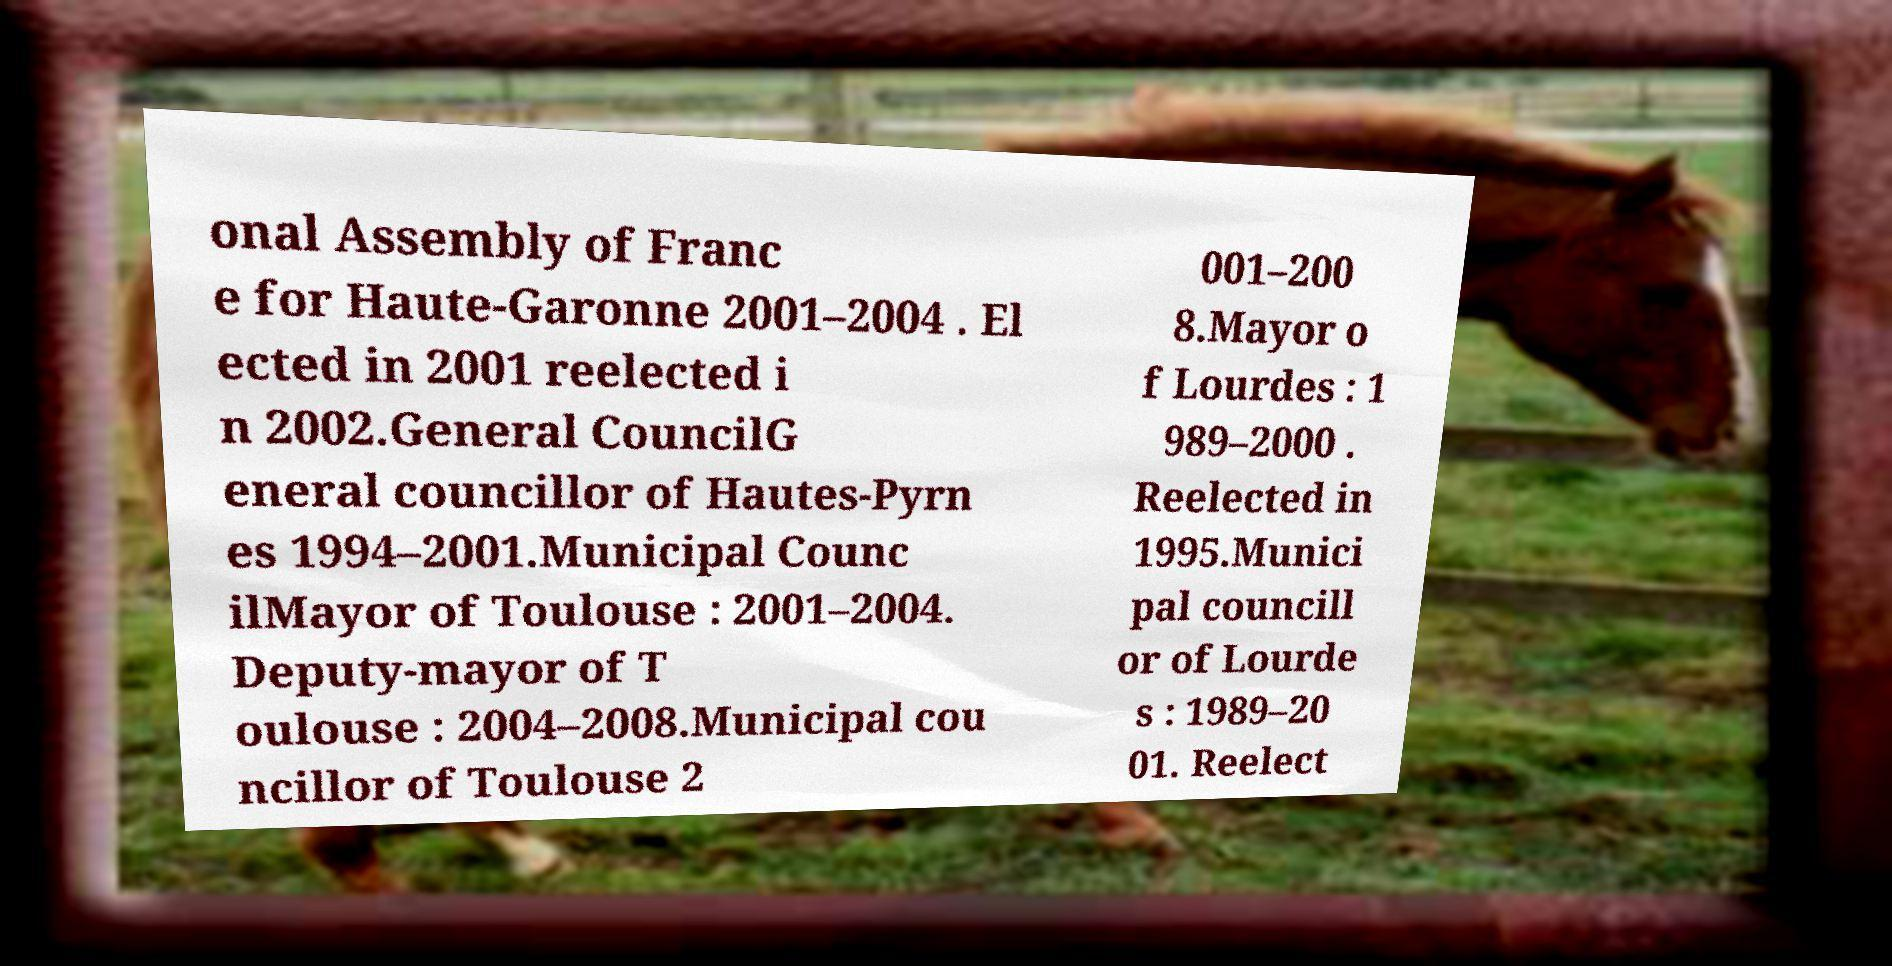For documentation purposes, I need the text within this image transcribed. Could you provide that? onal Assembly of Franc e for Haute-Garonne 2001–2004 . El ected in 2001 reelected i n 2002.General CouncilG eneral councillor of Hautes-Pyrn es 1994–2001.Municipal Counc ilMayor of Toulouse : 2001–2004. Deputy-mayor of T oulouse : 2004–2008.Municipal cou ncillor of Toulouse 2 001–200 8.Mayor o f Lourdes : 1 989–2000 . Reelected in 1995.Munici pal councill or of Lourde s : 1989–20 01. Reelect 